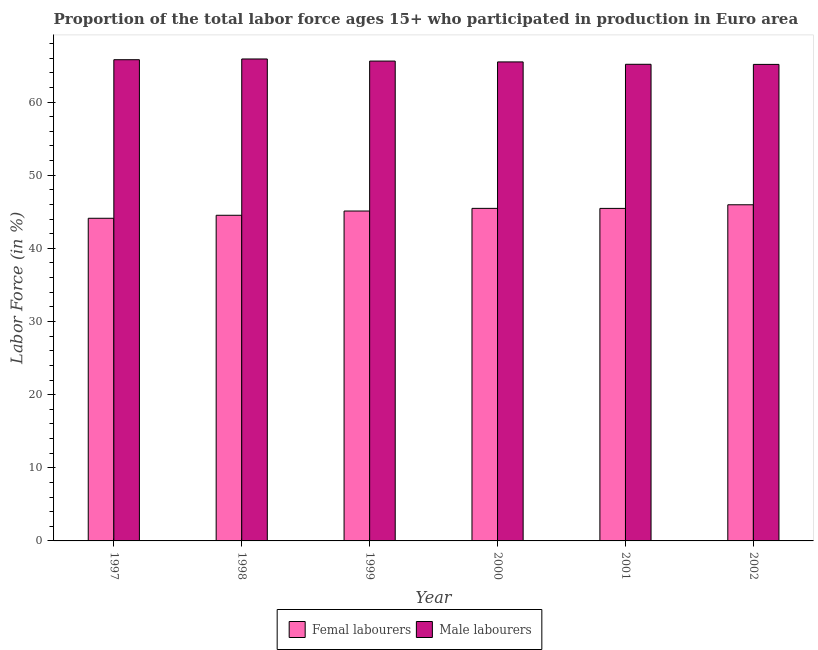How many different coloured bars are there?
Ensure brevity in your answer.  2. How many groups of bars are there?
Make the answer very short. 6. How many bars are there on the 5th tick from the left?
Offer a very short reply. 2. How many bars are there on the 4th tick from the right?
Offer a terse response. 2. In how many cases, is the number of bars for a given year not equal to the number of legend labels?
Your response must be concise. 0. What is the percentage of male labour force in 1998?
Keep it short and to the point. 65.89. Across all years, what is the maximum percentage of male labour force?
Your answer should be compact. 65.89. Across all years, what is the minimum percentage of male labour force?
Provide a succinct answer. 65.15. In which year was the percentage of female labor force maximum?
Ensure brevity in your answer.  2002. What is the total percentage of male labour force in the graph?
Your answer should be very brief. 393.11. What is the difference between the percentage of female labor force in 2000 and that in 2001?
Your answer should be very brief. 0. What is the difference between the percentage of male labour force in 1997 and the percentage of female labor force in 2001?
Your response must be concise. 0.63. What is the average percentage of female labor force per year?
Keep it short and to the point. 45.11. In the year 2001, what is the difference between the percentage of female labor force and percentage of male labour force?
Your answer should be very brief. 0. In how many years, is the percentage of male labour force greater than 32 %?
Give a very brief answer. 6. What is the ratio of the percentage of female labor force in 1997 to that in 2000?
Provide a short and direct response. 0.97. Is the percentage of male labour force in 2000 less than that in 2002?
Give a very brief answer. No. What is the difference between the highest and the second highest percentage of male labour force?
Your answer should be compact. 0.1. What is the difference between the highest and the lowest percentage of male labour force?
Offer a terse response. 0.74. In how many years, is the percentage of female labor force greater than the average percentage of female labor force taken over all years?
Provide a succinct answer. 4. Is the sum of the percentage of female labor force in 1999 and 2002 greater than the maximum percentage of male labour force across all years?
Provide a short and direct response. Yes. What does the 2nd bar from the left in 1998 represents?
Your answer should be compact. Male labourers. What does the 1st bar from the right in 2002 represents?
Give a very brief answer. Male labourers. How many bars are there?
Your answer should be compact. 12. How many years are there in the graph?
Make the answer very short. 6. What is the difference between two consecutive major ticks on the Y-axis?
Give a very brief answer. 10. Are the values on the major ticks of Y-axis written in scientific E-notation?
Your answer should be very brief. No. Does the graph contain any zero values?
Provide a succinct answer. No. Does the graph contain grids?
Make the answer very short. No. What is the title of the graph?
Keep it short and to the point. Proportion of the total labor force ages 15+ who participated in production in Euro area. What is the label or title of the X-axis?
Provide a short and direct response. Year. What is the Labor Force (in %) in Femal labourers in 1997?
Provide a succinct answer. 44.11. What is the Labor Force (in %) of Male labourers in 1997?
Your answer should be very brief. 65.79. What is the Labor Force (in %) of Femal labourers in 1998?
Make the answer very short. 44.52. What is the Labor Force (in %) in Male labourers in 1998?
Your answer should be compact. 65.89. What is the Labor Force (in %) in Femal labourers in 1999?
Offer a terse response. 45.11. What is the Labor Force (in %) in Male labourers in 1999?
Keep it short and to the point. 65.61. What is the Labor Force (in %) in Femal labourers in 2000?
Your answer should be very brief. 45.47. What is the Labor Force (in %) of Male labourers in 2000?
Ensure brevity in your answer.  65.49. What is the Labor Force (in %) of Femal labourers in 2001?
Your response must be concise. 45.46. What is the Labor Force (in %) of Male labourers in 2001?
Provide a short and direct response. 65.17. What is the Labor Force (in %) in Femal labourers in 2002?
Your answer should be compact. 45.96. What is the Labor Force (in %) of Male labourers in 2002?
Your answer should be compact. 65.15. Across all years, what is the maximum Labor Force (in %) of Femal labourers?
Make the answer very short. 45.96. Across all years, what is the maximum Labor Force (in %) of Male labourers?
Provide a short and direct response. 65.89. Across all years, what is the minimum Labor Force (in %) in Femal labourers?
Your response must be concise. 44.11. Across all years, what is the minimum Labor Force (in %) in Male labourers?
Provide a short and direct response. 65.15. What is the total Labor Force (in %) in Femal labourers in the graph?
Offer a terse response. 270.63. What is the total Labor Force (in %) of Male labourers in the graph?
Your answer should be compact. 393.11. What is the difference between the Labor Force (in %) of Femal labourers in 1997 and that in 1998?
Keep it short and to the point. -0.41. What is the difference between the Labor Force (in %) of Male labourers in 1997 and that in 1998?
Keep it short and to the point. -0.1. What is the difference between the Labor Force (in %) of Femal labourers in 1997 and that in 1999?
Make the answer very short. -0.99. What is the difference between the Labor Force (in %) of Male labourers in 1997 and that in 1999?
Provide a short and direct response. 0.19. What is the difference between the Labor Force (in %) of Femal labourers in 1997 and that in 2000?
Keep it short and to the point. -1.35. What is the difference between the Labor Force (in %) in Male labourers in 1997 and that in 2000?
Keep it short and to the point. 0.3. What is the difference between the Labor Force (in %) in Femal labourers in 1997 and that in 2001?
Your response must be concise. -1.35. What is the difference between the Labor Force (in %) in Male labourers in 1997 and that in 2001?
Provide a short and direct response. 0.63. What is the difference between the Labor Force (in %) of Femal labourers in 1997 and that in 2002?
Offer a very short reply. -1.85. What is the difference between the Labor Force (in %) of Male labourers in 1997 and that in 2002?
Offer a terse response. 0.64. What is the difference between the Labor Force (in %) in Femal labourers in 1998 and that in 1999?
Your answer should be very brief. -0.58. What is the difference between the Labor Force (in %) of Male labourers in 1998 and that in 1999?
Provide a succinct answer. 0.29. What is the difference between the Labor Force (in %) in Femal labourers in 1998 and that in 2000?
Your answer should be very brief. -0.94. What is the difference between the Labor Force (in %) in Male labourers in 1998 and that in 2000?
Your answer should be compact. 0.4. What is the difference between the Labor Force (in %) of Femal labourers in 1998 and that in 2001?
Offer a terse response. -0.94. What is the difference between the Labor Force (in %) of Male labourers in 1998 and that in 2001?
Give a very brief answer. 0.73. What is the difference between the Labor Force (in %) of Femal labourers in 1998 and that in 2002?
Keep it short and to the point. -1.44. What is the difference between the Labor Force (in %) in Male labourers in 1998 and that in 2002?
Your answer should be very brief. 0.74. What is the difference between the Labor Force (in %) of Femal labourers in 1999 and that in 2000?
Your response must be concise. -0.36. What is the difference between the Labor Force (in %) in Male labourers in 1999 and that in 2000?
Offer a very short reply. 0.12. What is the difference between the Labor Force (in %) of Femal labourers in 1999 and that in 2001?
Your answer should be very brief. -0.36. What is the difference between the Labor Force (in %) in Male labourers in 1999 and that in 2001?
Ensure brevity in your answer.  0.44. What is the difference between the Labor Force (in %) of Femal labourers in 1999 and that in 2002?
Your answer should be very brief. -0.85. What is the difference between the Labor Force (in %) in Male labourers in 1999 and that in 2002?
Offer a very short reply. 0.45. What is the difference between the Labor Force (in %) in Femal labourers in 2000 and that in 2001?
Your response must be concise. 0. What is the difference between the Labor Force (in %) of Male labourers in 2000 and that in 2001?
Give a very brief answer. 0.32. What is the difference between the Labor Force (in %) in Femal labourers in 2000 and that in 2002?
Ensure brevity in your answer.  -0.49. What is the difference between the Labor Force (in %) of Male labourers in 2000 and that in 2002?
Offer a terse response. 0.34. What is the difference between the Labor Force (in %) of Femal labourers in 2001 and that in 2002?
Provide a short and direct response. -0.5. What is the difference between the Labor Force (in %) of Male labourers in 2001 and that in 2002?
Make the answer very short. 0.01. What is the difference between the Labor Force (in %) in Femal labourers in 1997 and the Labor Force (in %) in Male labourers in 1998?
Make the answer very short. -21.78. What is the difference between the Labor Force (in %) of Femal labourers in 1997 and the Labor Force (in %) of Male labourers in 1999?
Ensure brevity in your answer.  -21.49. What is the difference between the Labor Force (in %) of Femal labourers in 1997 and the Labor Force (in %) of Male labourers in 2000?
Give a very brief answer. -21.38. What is the difference between the Labor Force (in %) of Femal labourers in 1997 and the Labor Force (in %) of Male labourers in 2001?
Your answer should be compact. -21.05. What is the difference between the Labor Force (in %) in Femal labourers in 1997 and the Labor Force (in %) in Male labourers in 2002?
Your answer should be compact. -21.04. What is the difference between the Labor Force (in %) of Femal labourers in 1998 and the Labor Force (in %) of Male labourers in 1999?
Keep it short and to the point. -21.08. What is the difference between the Labor Force (in %) of Femal labourers in 1998 and the Labor Force (in %) of Male labourers in 2000?
Give a very brief answer. -20.97. What is the difference between the Labor Force (in %) of Femal labourers in 1998 and the Labor Force (in %) of Male labourers in 2001?
Make the answer very short. -20.64. What is the difference between the Labor Force (in %) of Femal labourers in 1998 and the Labor Force (in %) of Male labourers in 2002?
Provide a succinct answer. -20.63. What is the difference between the Labor Force (in %) of Femal labourers in 1999 and the Labor Force (in %) of Male labourers in 2000?
Provide a short and direct response. -20.39. What is the difference between the Labor Force (in %) in Femal labourers in 1999 and the Labor Force (in %) in Male labourers in 2001?
Keep it short and to the point. -20.06. What is the difference between the Labor Force (in %) in Femal labourers in 1999 and the Labor Force (in %) in Male labourers in 2002?
Provide a succinct answer. -20.05. What is the difference between the Labor Force (in %) in Femal labourers in 2000 and the Labor Force (in %) in Male labourers in 2001?
Provide a succinct answer. -19.7. What is the difference between the Labor Force (in %) in Femal labourers in 2000 and the Labor Force (in %) in Male labourers in 2002?
Make the answer very short. -19.69. What is the difference between the Labor Force (in %) in Femal labourers in 2001 and the Labor Force (in %) in Male labourers in 2002?
Give a very brief answer. -19.69. What is the average Labor Force (in %) of Femal labourers per year?
Provide a short and direct response. 45.11. What is the average Labor Force (in %) of Male labourers per year?
Your answer should be very brief. 65.52. In the year 1997, what is the difference between the Labor Force (in %) of Femal labourers and Labor Force (in %) of Male labourers?
Offer a very short reply. -21.68. In the year 1998, what is the difference between the Labor Force (in %) in Femal labourers and Labor Force (in %) in Male labourers?
Your response must be concise. -21.37. In the year 1999, what is the difference between the Labor Force (in %) of Femal labourers and Labor Force (in %) of Male labourers?
Your answer should be very brief. -20.5. In the year 2000, what is the difference between the Labor Force (in %) of Femal labourers and Labor Force (in %) of Male labourers?
Offer a very short reply. -20.02. In the year 2001, what is the difference between the Labor Force (in %) in Femal labourers and Labor Force (in %) in Male labourers?
Your response must be concise. -19.7. In the year 2002, what is the difference between the Labor Force (in %) of Femal labourers and Labor Force (in %) of Male labourers?
Offer a very short reply. -19.19. What is the ratio of the Labor Force (in %) of Femal labourers in 1997 to that in 2000?
Provide a succinct answer. 0.97. What is the ratio of the Labor Force (in %) of Femal labourers in 1997 to that in 2001?
Keep it short and to the point. 0.97. What is the ratio of the Labor Force (in %) of Male labourers in 1997 to that in 2001?
Keep it short and to the point. 1.01. What is the ratio of the Labor Force (in %) of Femal labourers in 1997 to that in 2002?
Your response must be concise. 0.96. What is the ratio of the Labor Force (in %) in Male labourers in 1997 to that in 2002?
Your response must be concise. 1.01. What is the ratio of the Labor Force (in %) in Femal labourers in 1998 to that in 1999?
Provide a succinct answer. 0.99. What is the ratio of the Labor Force (in %) in Femal labourers in 1998 to that in 2000?
Provide a short and direct response. 0.98. What is the ratio of the Labor Force (in %) of Male labourers in 1998 to that in 2000?
Ensure brevity in your answer.  1.01. What is the ratio of the Labor Force (in %) in Femal labourers in 1998 to that in 2001?
Ensure brevity in your answer.  0.98. What is the ratio of the Labor Force (in %) of Male labourers in 1998 to that in 2001?
Your response must be concise. 1.01. What is the ratio of the Labor Force (in %) of Femal labourers in 1998 to that in 2002?
Ensure brevity in your answer.  0.97. What is the ratio of the Labor Force (in %) of Male labourers in 1998 to that in 2002?
Provide a short and direct response. 1.01. What is the ratio of the Labor Force (in %) in Femal labourers in 1999 to that in 2001?
Provide a succinct answer. 0.99. What is the ratio of the Labor Force (in %) in Male labourers in 1999 to that in 2001?
Ensure brevity in your answer.  1.01. What is the ratio of the Labor Force (in %) of Femal labourers in 1999 to that in 2002?
Your answer should be very brief. 0.98. What is the ratio of the Labor Force (in %) of Male labourers in 1999 to that in 2002?
Make the answer very short. 1.01. What is the ratio of the Labor Force (in %) of Femal labourers in 2000 to that in 2001?
Your answer should be very brief. 1. What is the ratio of the Labor Force (in %) of Femal labourers in 2000 to that in 2002?
Give a very brief answer. 0.99. What is the ratio of the Labor Force (in %) of Male labourers in 2000 to that in 2002?
Make the answer very short. 1.01. What is the difference between the highest and the second highest Labor Force (in %) in Femal labourers?
Your answer should be compact. 0.49. What is the difference between the highest and the second highest Labor Force (in %) of Male labourers?
Offer a very short reply. 0.1. What is the difference between the highest and the lowest Labor Force (in %) of Femal labourers?
Offer a very short reply. 1.85. What is the difference between the highest and the lowest Labor Force (in %) of Male labourers?
Provide a short and direct response. 0.74. 